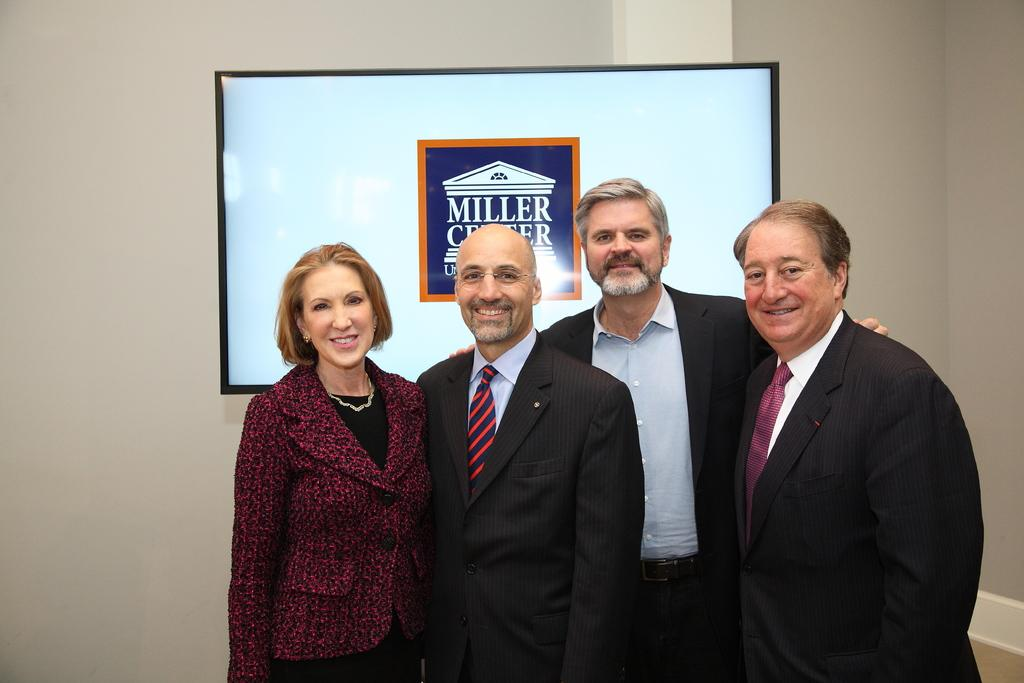How many people are in the image? There are persons standing in the image. What surface are the persons standing on? The persons are standing on the floor. What can be seen in the background of the image? There is a television and a wall in the background of the image. How many cats are sitting on the gate in the image? There are no cats or gates present in the image. What type of snails can be seen crawling on the wall in the image? There are no snails visible in the image; only a television and a wall are present in the background. 